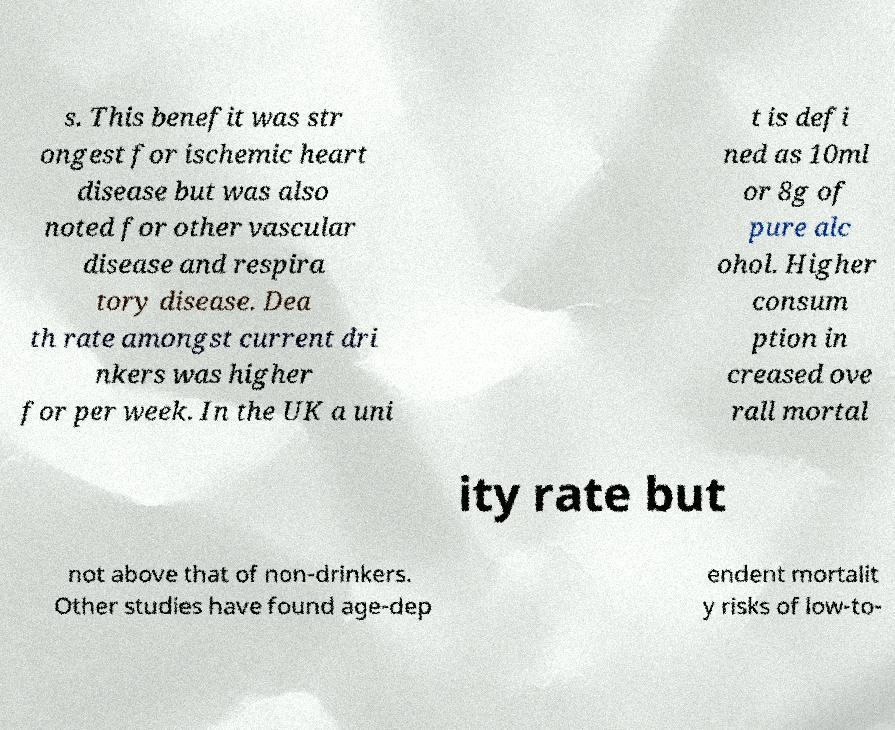For documentation purposes, I need the text within this image transcribed. Could you provide that? s. This benefit was str ongest for ischemic heart disease but was also noted for other vascular disease and respira tory disease. Dea th rate amongst current dri nkers was higher for per week. In the UK a uni t is defi ned as 10ml or 8g of pure alc ohol. Higher consum ption in creased ove rall mortal ity rate but not above that of non-drinkers. Other studies have found age-dep endent mortalit y risks of low-to- 